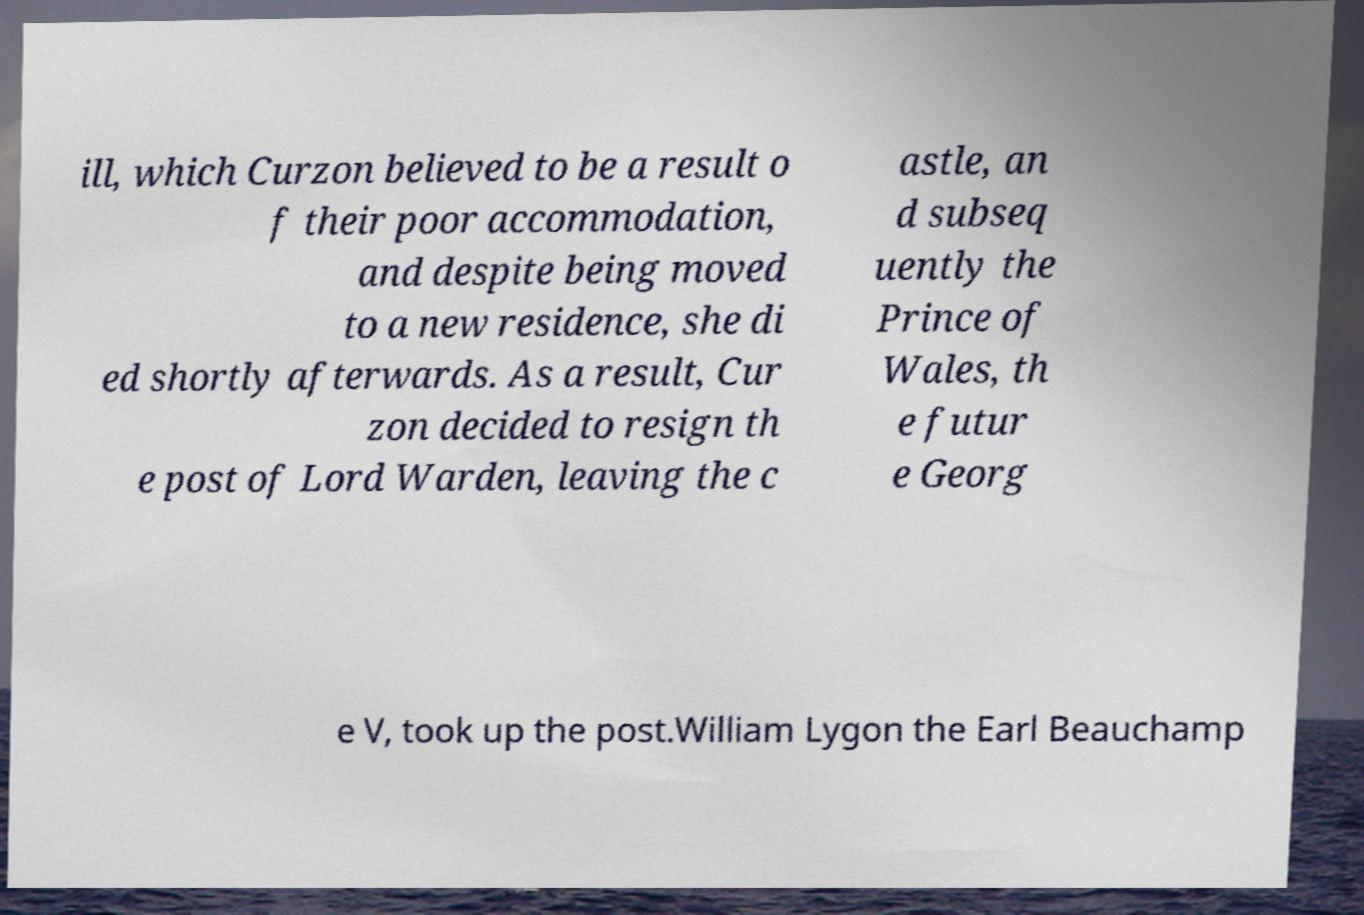Please identify and transcribe the text found in this image. ill, which Curzon believed to be a result o f their poor accommodation, and despite being moved to a new residence, she di ed shortly afterwards. As a result, Cur zon decided to resign th e post of Lord Warden, leaving the c astle, an d subseq uently the Prince of Wales, th e futur e Georg e V, took up the post.William Lygon the Earl Beauchamp 